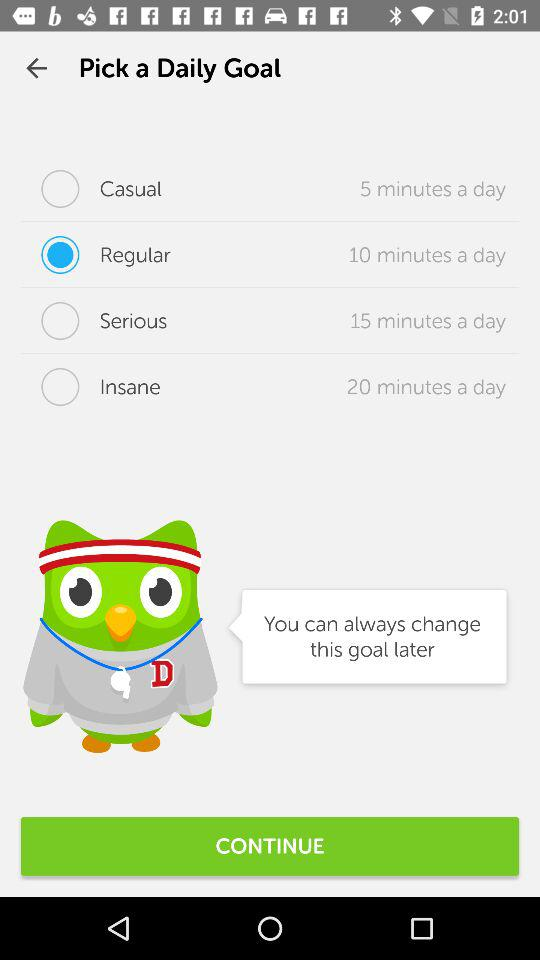What time duration is mentioned for the "Casual" daily goal? The mentioned time duration is 5 minutes a day. 